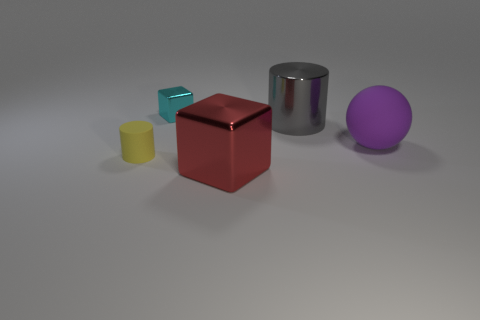Add 2 large purple objects. How many objects exist? 7 Subtract all balls. How many objects are left? 4 Subtract 0 green cylinders. How many objects are left? 5 Subtract all small purple shiny blocks. Subtract all small rubber cylinders. How many objects are left? 4 Add 4 gray things. How many gray things are left? 5 Add 4 large gray objects. How many large gray objects exist? 5 